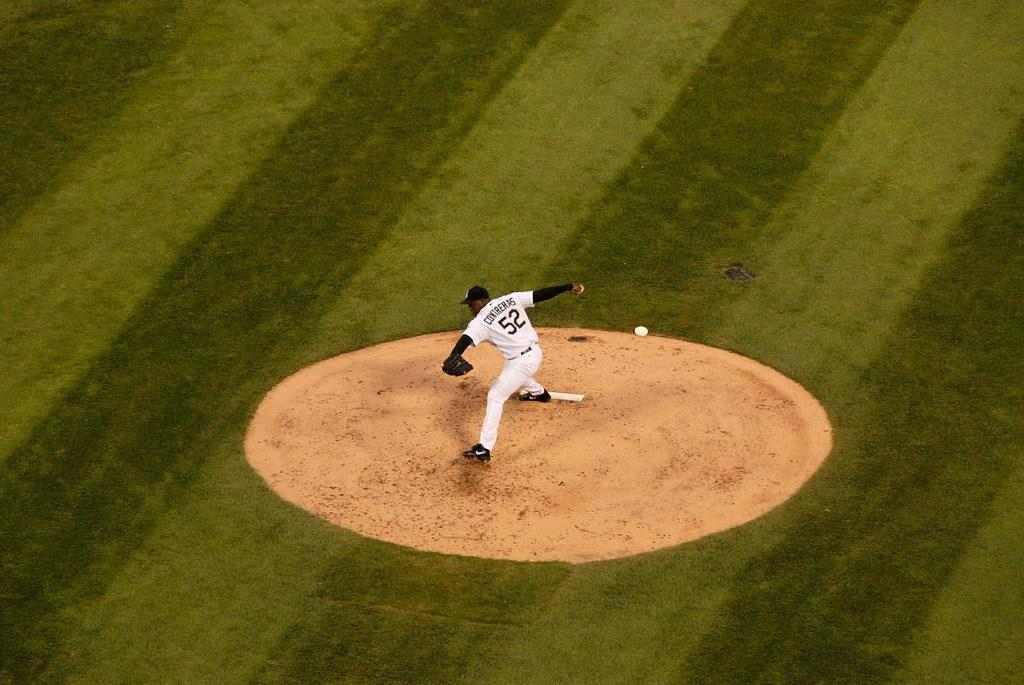<image>
Provide a brief description of the given image. Contreras wears number 52 and he is about to throw the ball. 